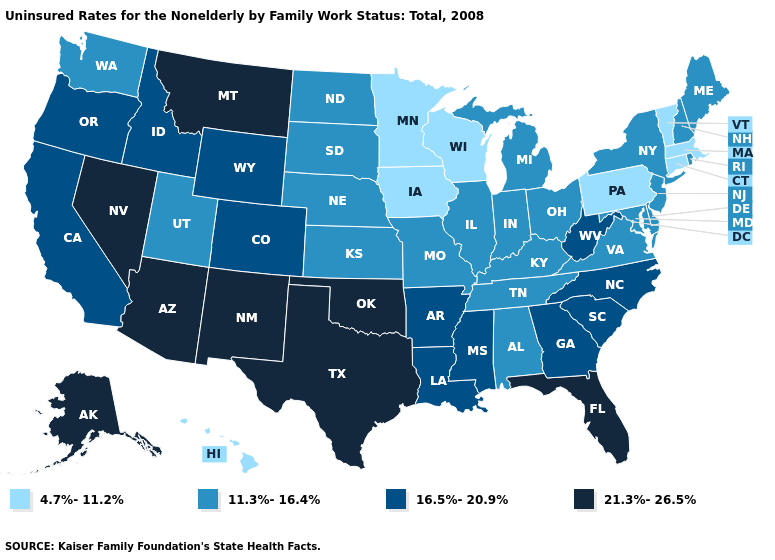Among the states that border Massachusetts , does New Hampshire have the highest value?
Keep it brief. Yes. What is the value of Utah?
Answer briefly. 11.3%-16.4%. Does Iowa have the same value as Connecticut?
Write a very short answer. Yes. Name the states that have a value in the range 4.7%-11.2%?
Give a very brief answer. Connecticut, Hawaii, Iowa, Massachusetts, Minnesota, Pennsylvania, Vermont, Wisconsin. Does Oregon have the lowest value in the USA?
Short answer required. No. How many symbols are there in the legend?
Concise answer only. 4. Which states have the lowest value in the USA?
Keep it brief. Connecticut, Hawaii, Iowa, Massachusetts, Minnesota, Pennsylvania, Vermont, Wisconsin. What is the value of Alabama?
Give a very brief answer. 11.3%-16.4%. What is the highest value in the MidWest ?
Quick response, please. 11.3%-16.4%. What is the value of Colorado?
Keep it brief. 16.5%-20.9%. What is the lowest value in the USA?
Short answer required. 4.7%-11.2%. Name the states that have a value in the range 11.3%-16.4%?
Be succinct. Alabama, Delaware, Illinois, Indiana, Kansas, Kentucky, Maine, Maryland, Michigan, Missouri, Nebraska, New Hampshire, New Jersey, New York, North Dakota, Ohio, Rhode Island, South Dakota, Tennessee, Utah, Virginia, Washington. Which states hav the highest value in the MidWest?
Give a very brief answer. Illinois, Indiana, Kansas, Michigan, Missouri, Nebraska, North Dakota, Ohio, South Dakota. What is the lowest value in states that border Florida?
Be succinct. 11.3%-16.4%. Among the states that border New Mexico , which have the highest value?
Write a very short answer. Arizona, Oklahoma, Texas. 